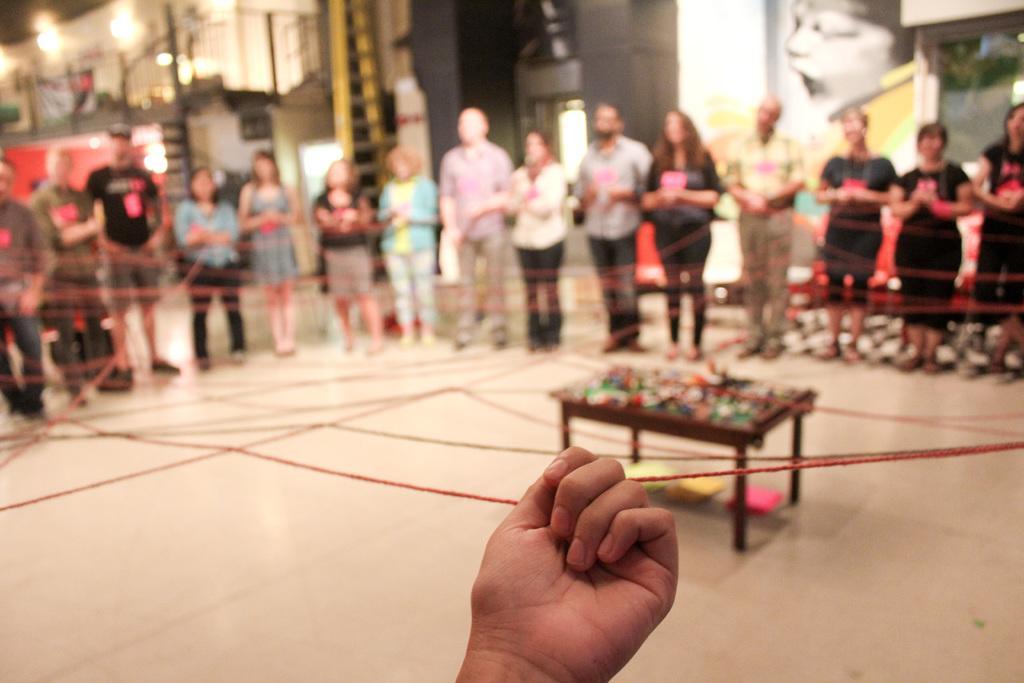Could you give a brief overview of what you see in this image? In this image, There is a floor which is in white color and in the middle there is a person hand and he is holding a thread which is red color, There are some people standing and they are holding the threads which is in red color. 